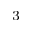Convert formula to latex. <formula><loc_0><loc_0><loc_500><loc_500>^ { 3 }</formula> 